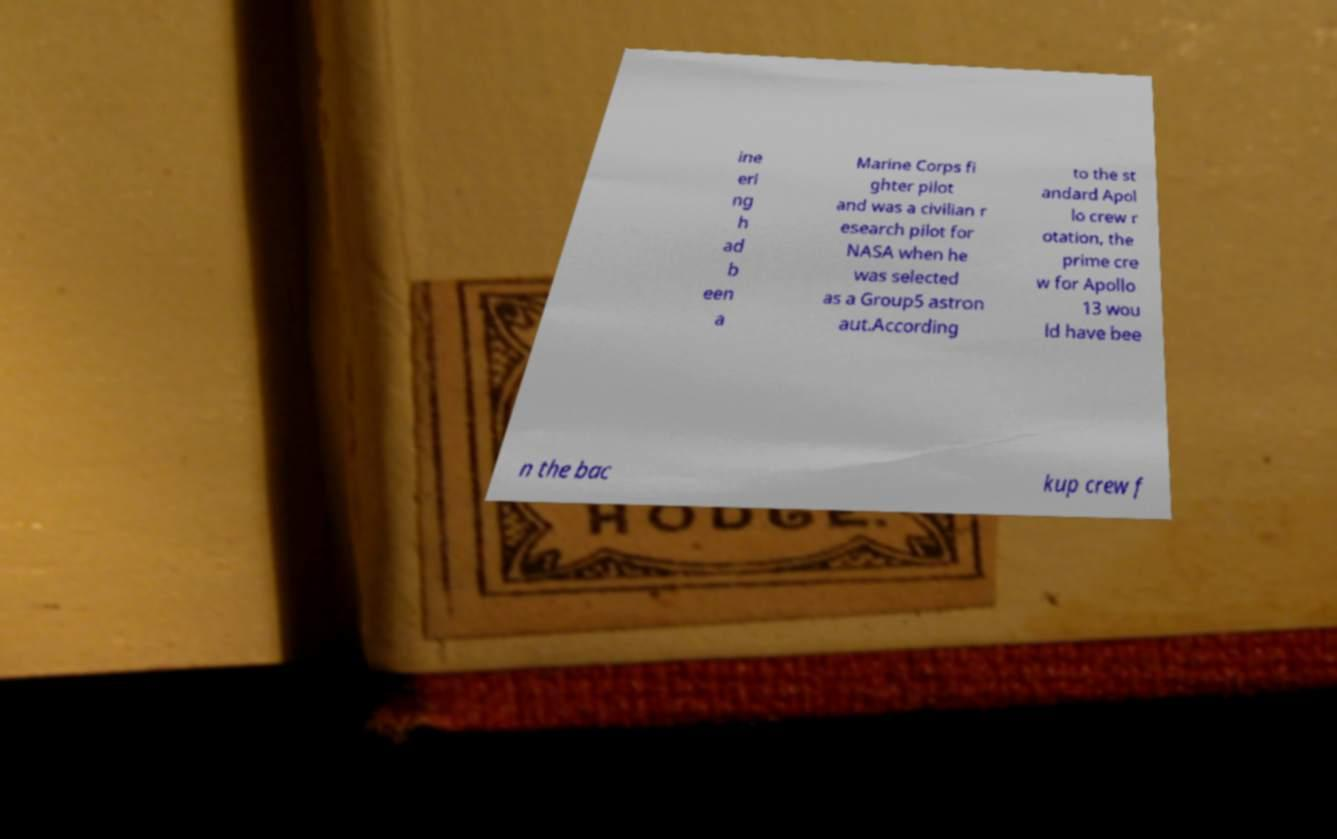Can you read and provide the text displayed in the image?This photo seems to have some interesting text. Can you extract and type it out for me? ine eri ng h ad b een a Marine Corps fi ghter pilot and was a civilian r esearch pilot for NASA when he was selected as a Group5 astron aut.According to the st andard Apol lo crew r otation, the prime cre w for Apollo 13 wou ld have bee n the bac kup crew f 